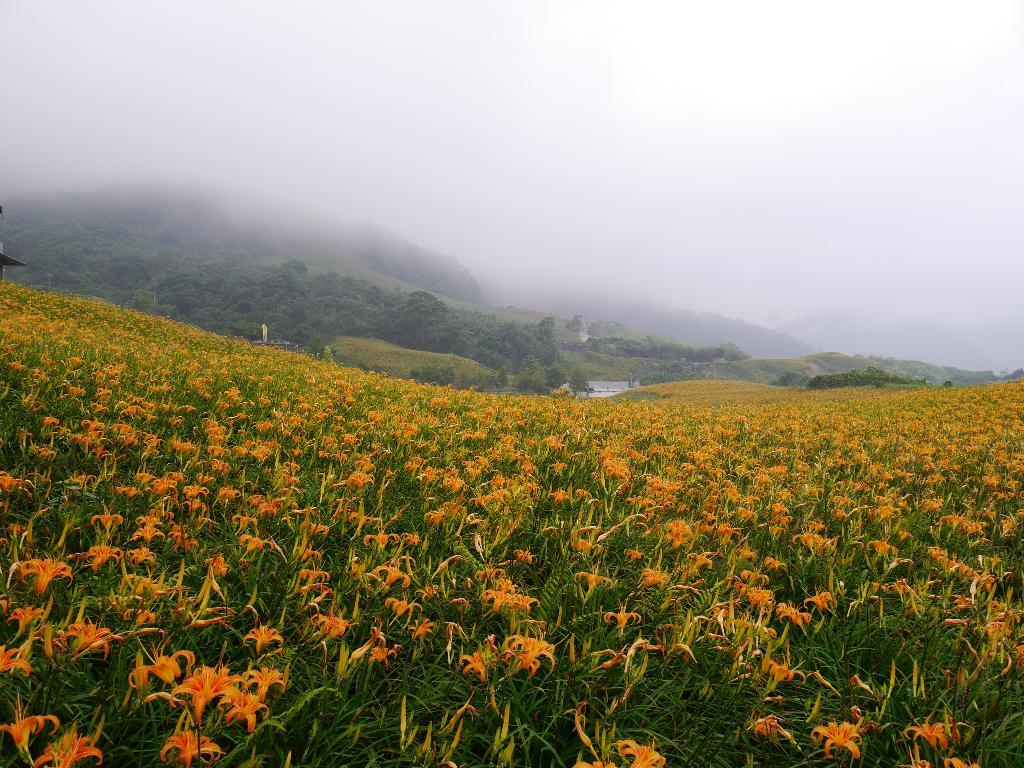What type of vegetation can be seen in the image? There are flower plants and trees in the image. What part of the natural environment is visible in the image? The sky is visible in the image. What type of harmony can be heard in the image? There is no sound or music present in the image, so it is not possible to determine what type of harmony might be heard. 